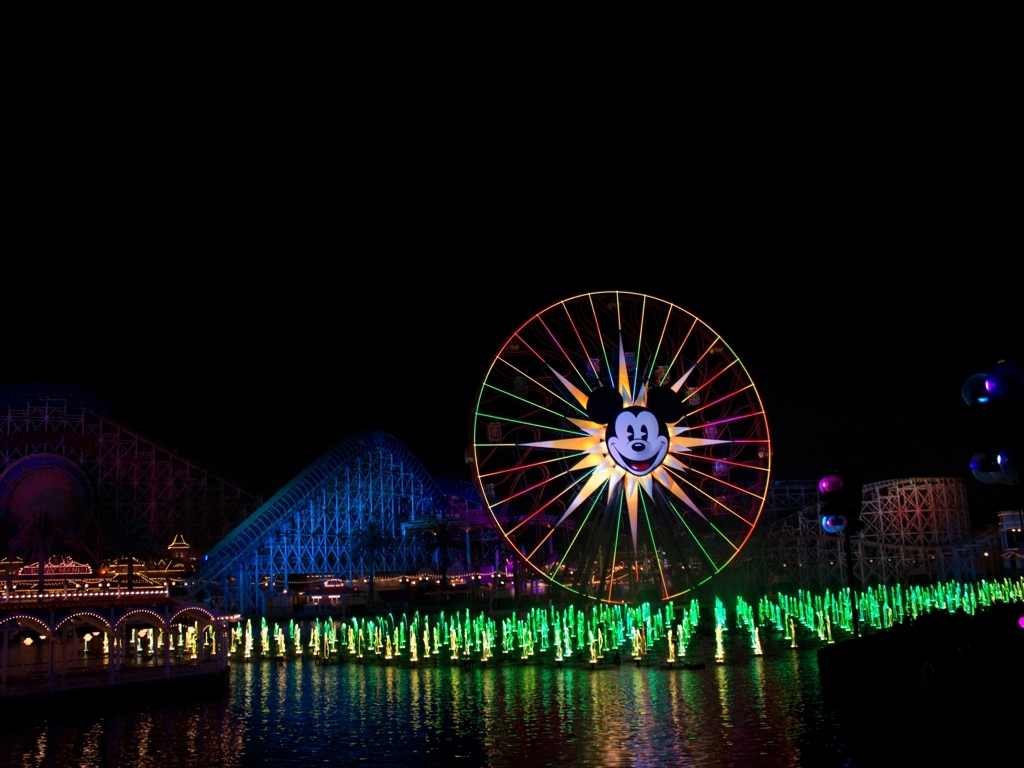Are there any loss of details in the dark areas of the background? Upon reviewing the image, there does appear to be a slight loss of detail in the darker areas of the background, likely due to the contrasting bright lights of the foreground attractions. It results in some portions being less discernible, particularly in the mid to far distances where the shadows dominate. 